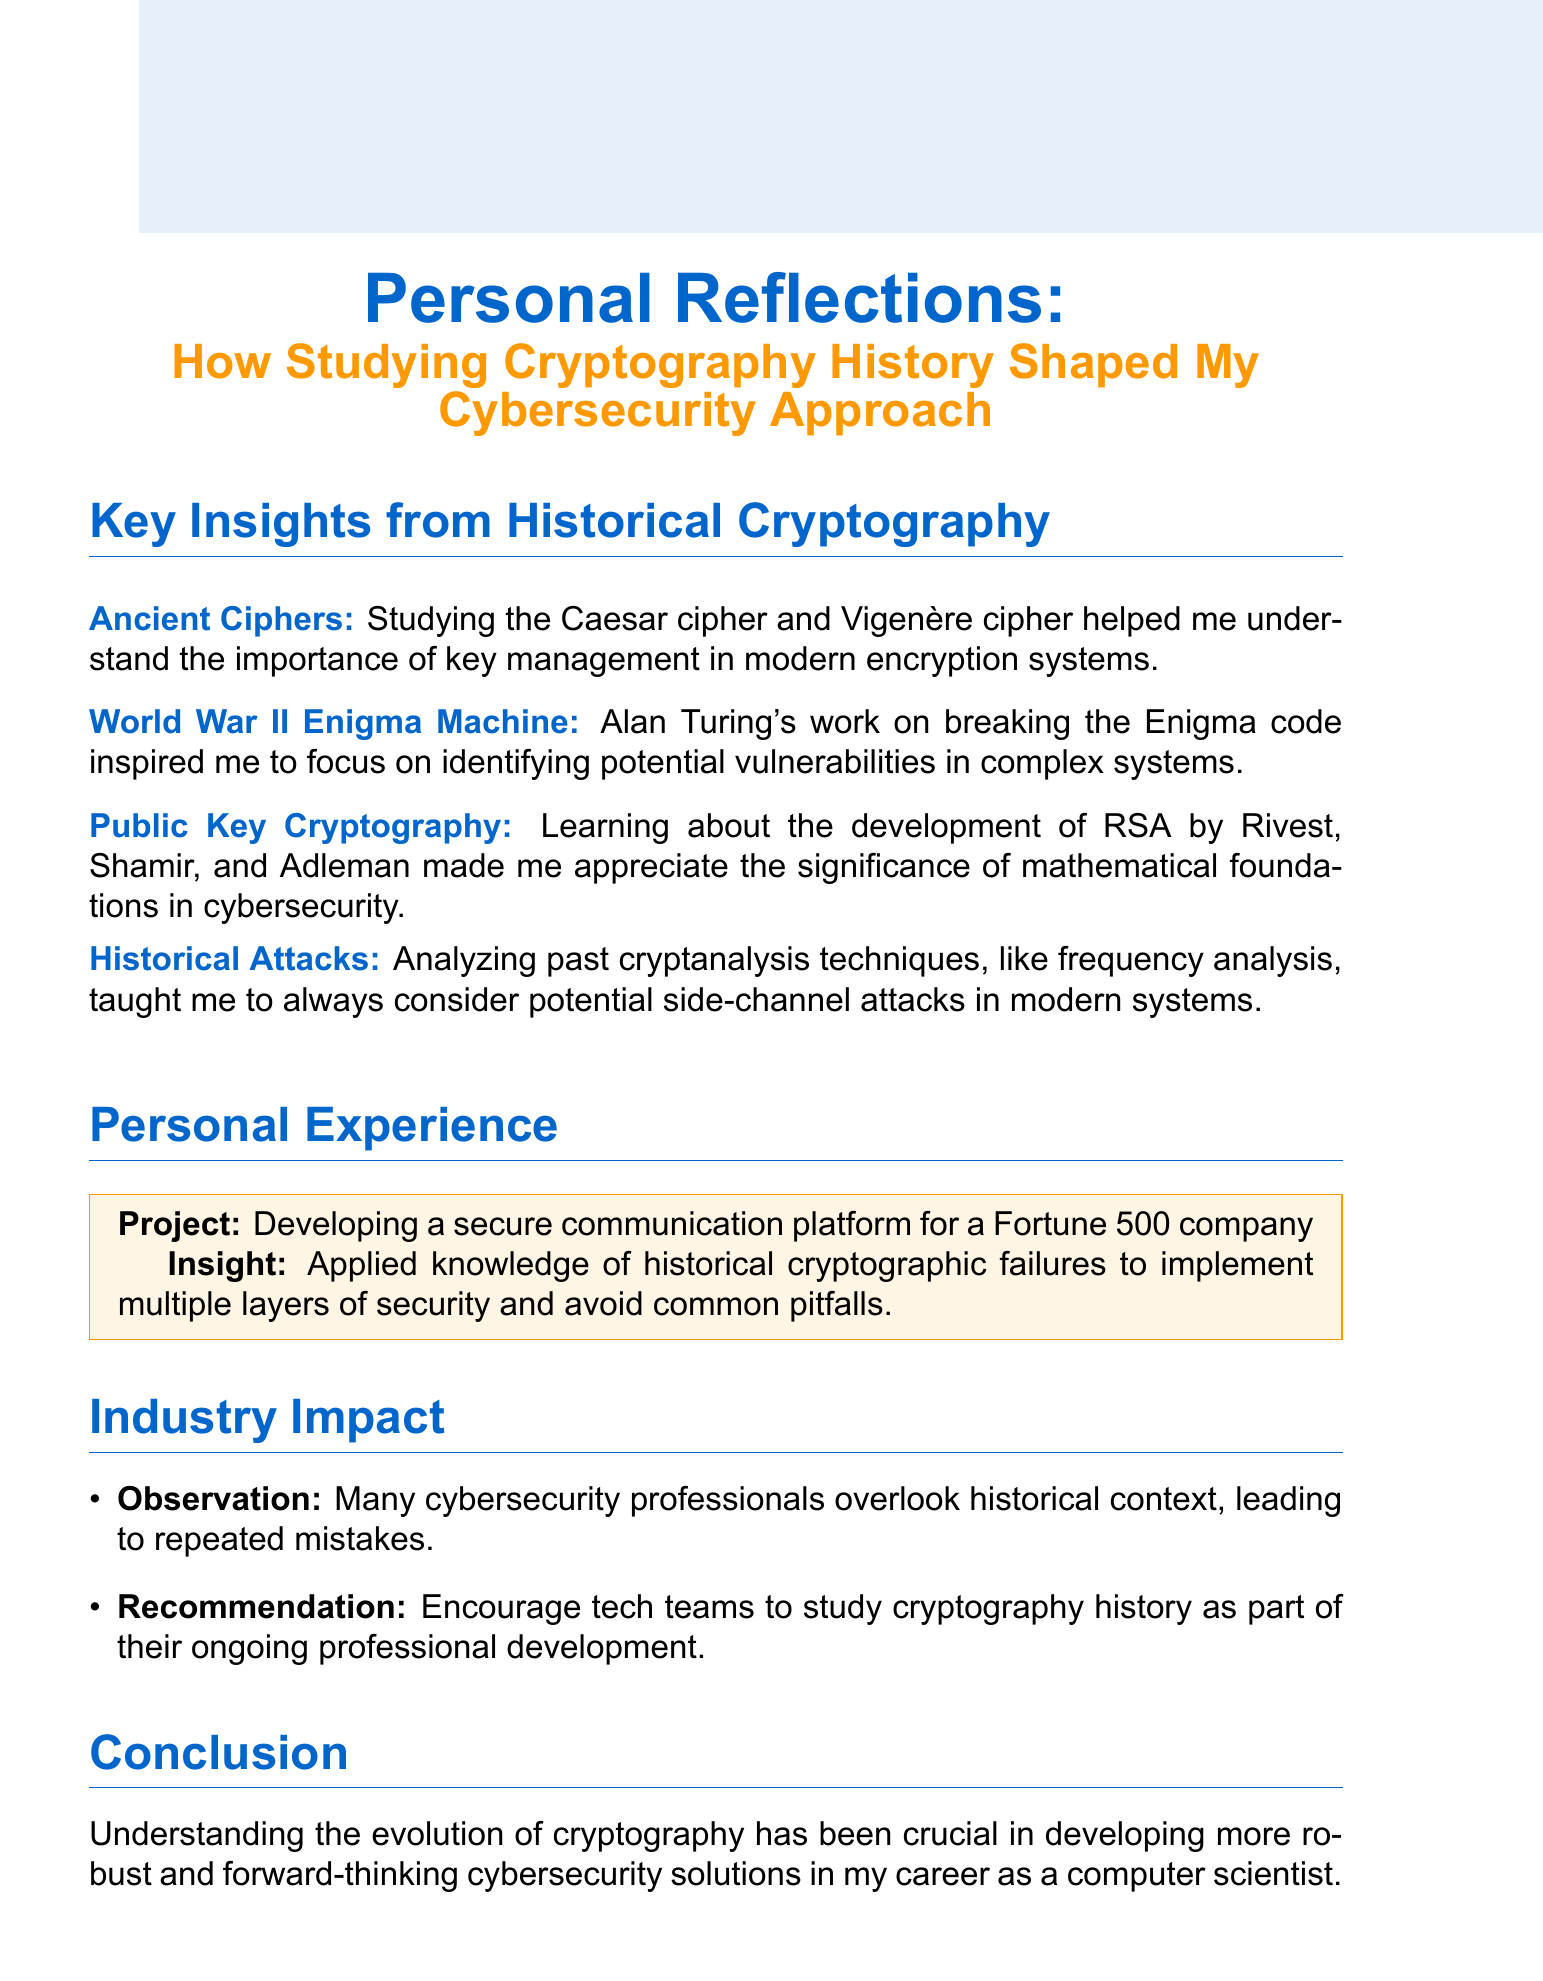What is the title of the document? The title of the document is specified at the beginning of the text, which discusses personal reflections on cryptography.
Answer: Personal Reflections: How Studying Cryptography History Shaped My Cybersecurity Approach Which ancient ciphers are mentioned? The document lists ancient ciphers that influenced the author's understanding of key management.
Answer: Caesar cipher and Vigenère cipher Who inspired the focus on identifying vulnerabilities in complex systems? The document cites a historical figure whose work on a specific code influenced the author's approach to cybersecurity.
Answer: Alan Turing What significant development is associated with Rivest, Shamir, and Adleman? The reflection discusses a major cryptographic advancement linked to their names.
Answer: RSA What did analyzing past cryptanalysis techniques teach? The document explains a lesson learned from historical techniques regarding modern cybersecurity practices.
Answer: Consider potential side-channel attacks What was the personal project mentioned? The text includes information about a specific project that the author worked on related to secure communication.
Answer: Developing a secure communication platform for a Fortune 500 company What is the observation about many cybersecurity professionals? The document states a common issue observed among cybersecurity professionals concerning their approach.
Answer: They overlook historical context What does the author recommend for tech teams? The text provides advice for improving cybersecurity expertise among teams, based on the author's insights.
Answer: Study cryptography history as part of their ongoing professional development What conclusion is drawn about the evolution of cryptography? The final reflection emphasizes the importance of historical knowledge in cybersecurity.
Answer: Crucial for developing more robust solutions 